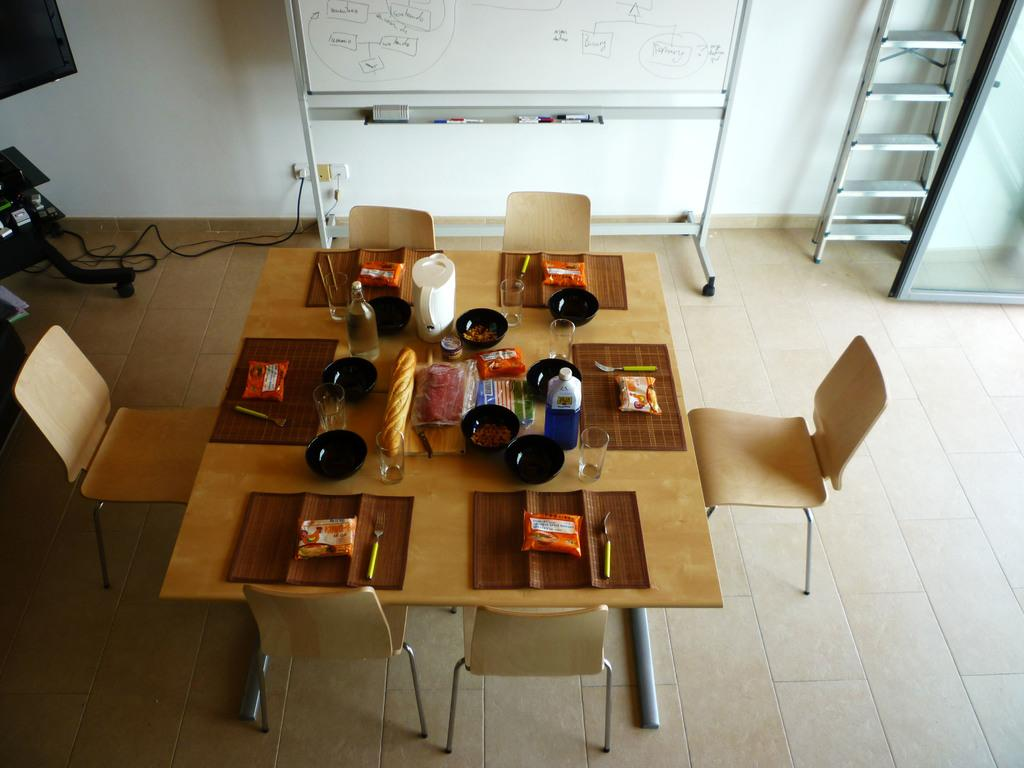What type of furniture is on the floor in the image? There is a dining table on the floor in the image. What items can be seen on the dining table? There are glasses, forks, and a bottle on the dining table. What structures are visible in the image? There is a wall, a board, and a ladder in the image. What type of fear can be seen on the face of the beast in the image? There is no beast or fear present in the image; it only features a dining table, glasses, forks, a bottle, a wall, a board, and a ladder. 